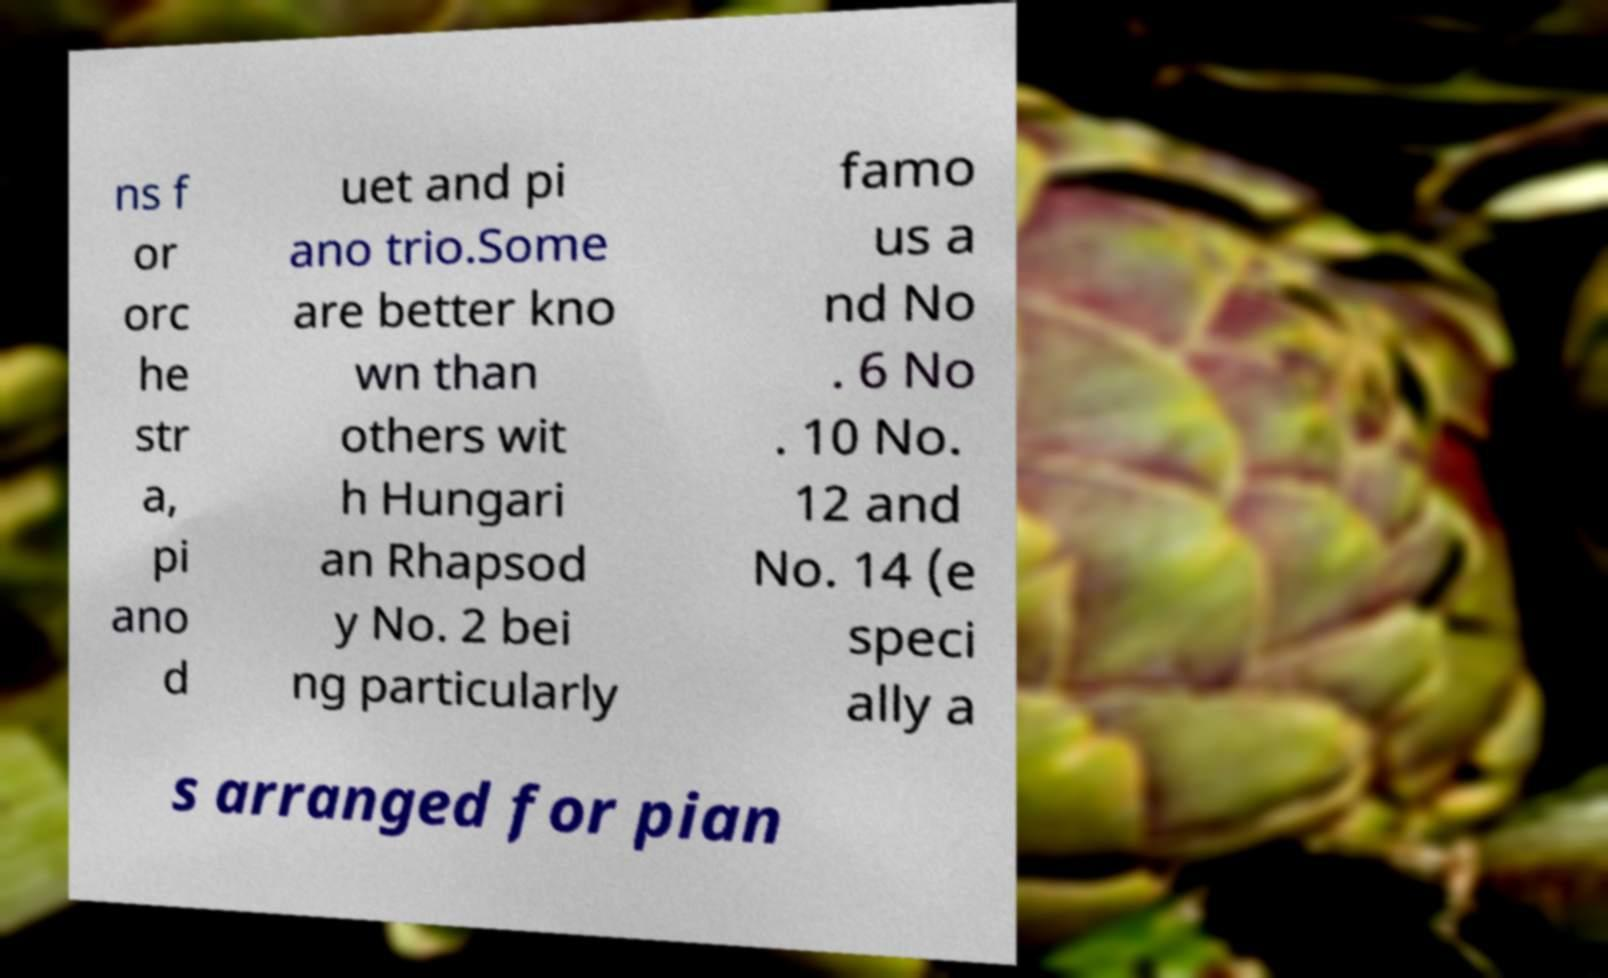Can you accurately transcribe the text from the provided image for me? ns f or orc he str a, pi ano d uet and pi ano trio.Some are better kno wn than others wit h Hungari an Rhapsod y No. 2 bei ng particularly famo us a nd No . 6 No . 10 No. 12 and No. 14 (e speci ally a s arranged for pian 